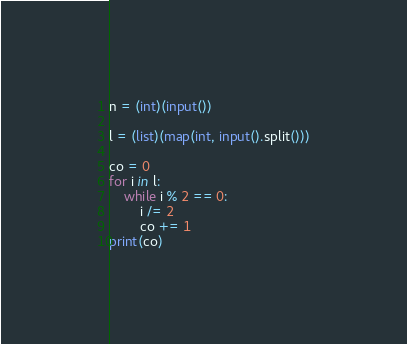<code> <loc_0><loc_0><loc_500><loc_500><_Python_>n = (int)(input())

l = (list)(map(int, input().split()))

co = 0
for i in l:
    while i % 2 == 0:
        i /= 2
        co += 1
print(co)
</code> 